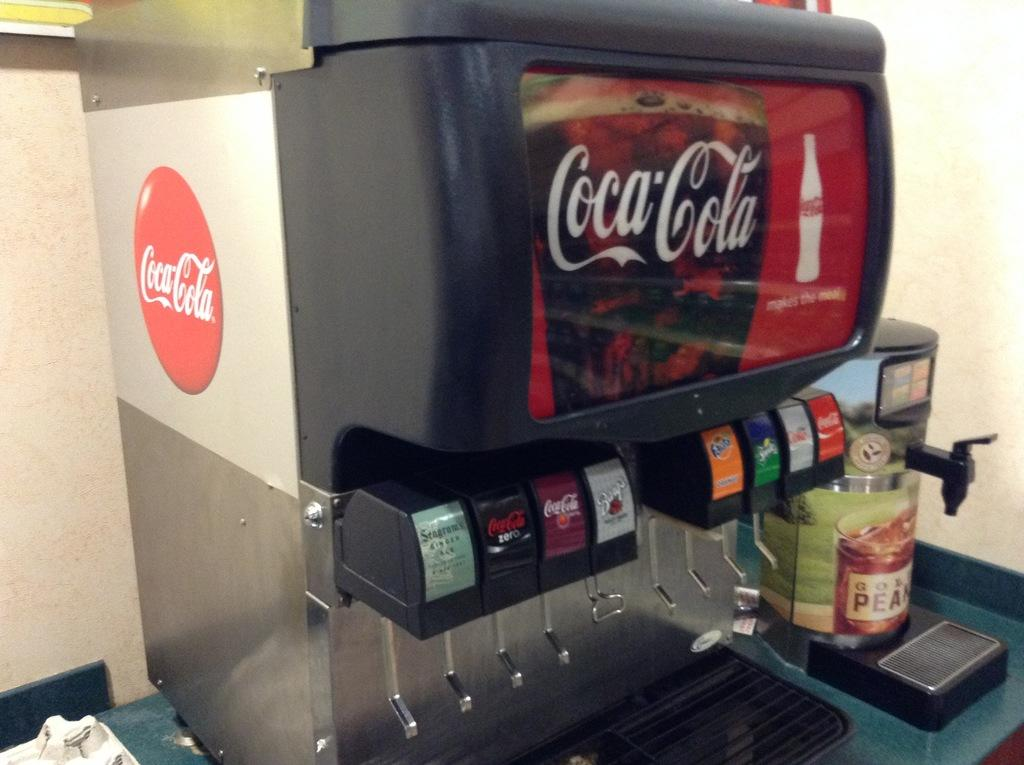<image>
Write a terse but informative summary of the picture. a soda fountain with the coca cola logo on it 